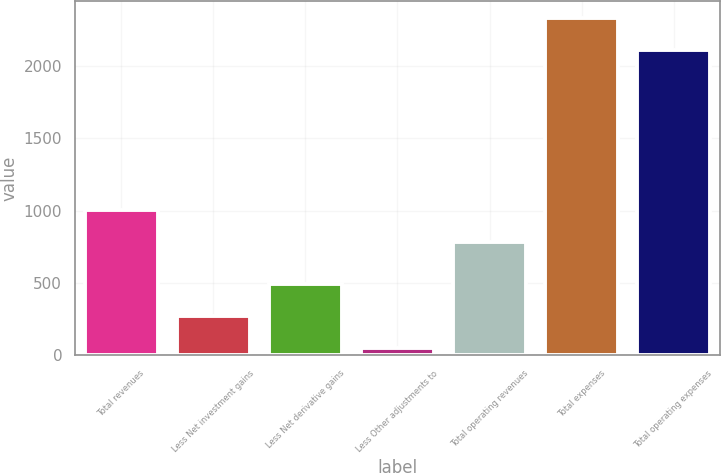Convert chart to OTSL. <chart><loc_0><loc_0><loc_500><loc_500><bar_chart><fcel>Total revenues<fcel>Less Net investment gains<fcel>Less Net derivative gains<fcel>Less Other adjustments to<fcel>Total operating revenues<fcel>Total expenses<fcel>Total operating expenses<nl><fcel>1004.9<fcel>275.9<fcel>496.8<fcel>55<fcel>784<fcel>2331.9<fcel>2111<nl></chart> 